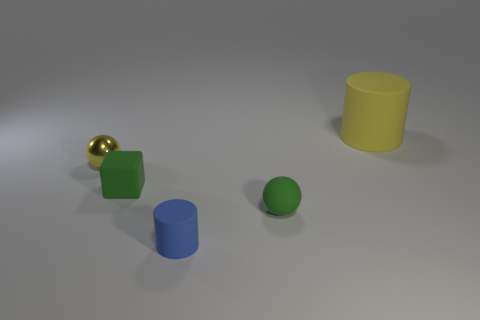Subtract all cylinders. How many objects are left? 3 Subtract all cyan cubes. How many yellow cylinders are left? 1 Subtract all small yellow matte things. Subtract all tiny matte spheres. How many objects are left? 4 Add 4 blue objects. How many blue objects are left? 5 Add 1 small blue matte cylinders. How many small blue matte cylinders exist? 2 Add 2 large yellow rubber blocks. How many objects exist? 7 Subtract all yellow spheres. How many spheres are left? 1 Subtract 1 green cubes. How many objects are left? 4 Subtract all brown cylinders. Subtract all green spheres. How many cylinders are left? 2 